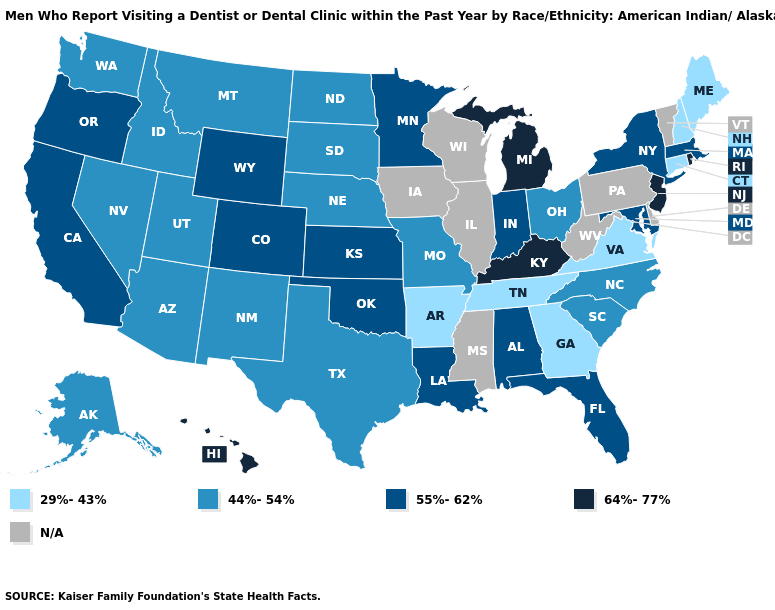What is the highest value in states that border Missouri?
Concise answer only. 64%-77%. What is the value of Rhode Island?
Short answer required. 64%-77%. Which states have the lowest value in the USA?
Be succinct. Arkansas, Connecticut, Georgia, Maine, New Hampshire, Tennessee, Virginia. Does the map have missing data?
Be succinct. Yes. What is the value of Montana?
Answer briefly. 44%-54%. Name the states that have a value in the range N/A?
Write a very short answer. Delaware, Illinois, Iowa, Mississippi, Pennsylvania, Vermont, West Virginia, Wisconsin. Does Indiana have the highest value in the USA?
Give a very brief answer. No. Does New Hampshire have the lowest value in the Northeast?
Be succinct. Yes. Name the states that have a value in the range 55%-62%?
Answer briefly. Alabama, California, Colorado, Florida, Indiana, Kansas, Louisiana, Maryland, Massachusetts, Minnesota, New York, Oklahoma, Oregon, Wyoming. What is the lowest value in the USA?
Be succinct. 29%-43%. Name the states that have a value in the range N/A?
Be succinct. Delaware, Illinois, Iowa, Mississippi, Pennsylvania, Vermont, West Virginia, Wisconsin. How many symbols are there in the legend?
Keep it brief. 5. Is the legend a continuous bar?
Keep it brief. No. Among the states that border Maine , which have the lowest value?
Short answer required. New Hampshire. What is the highest value in states that border Kentucky?
Concise answer only. 55%-62%. 